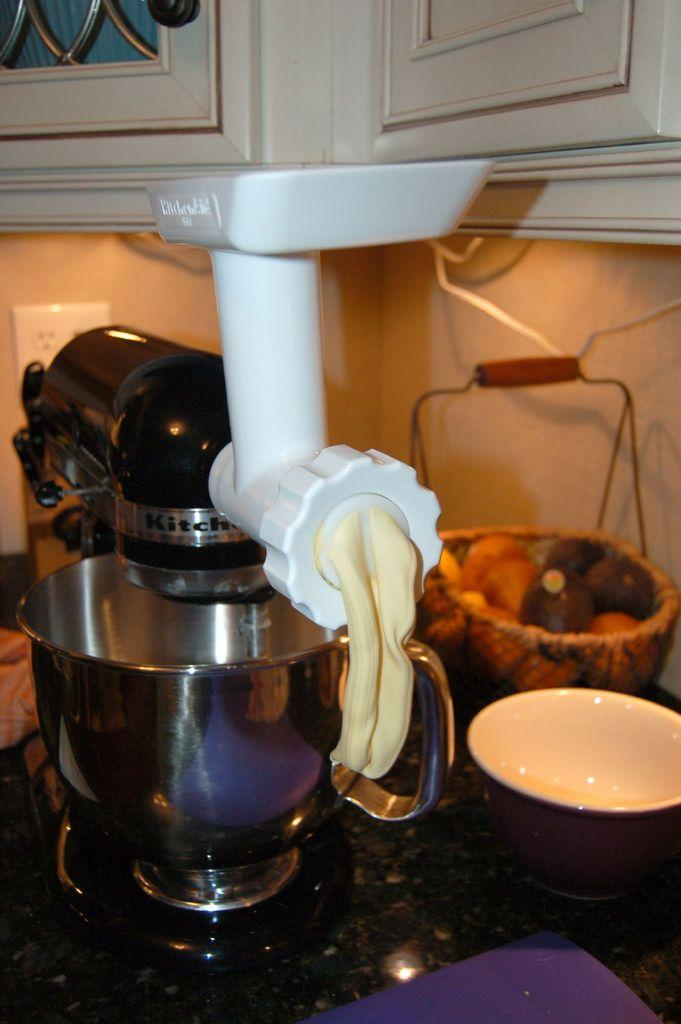Provide a one-sentence caption for the provided image. A Kitchen-Aid brand mixer dispensing a creamy looking substance. 